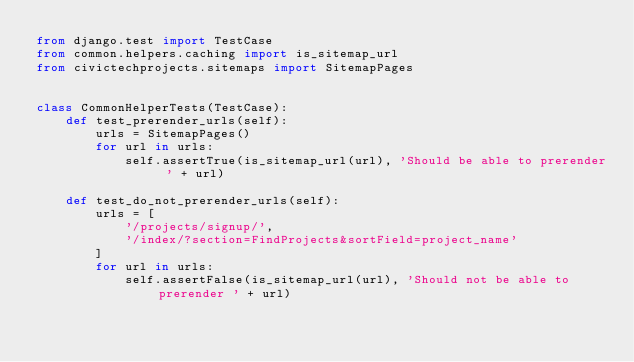Convert code to text. <code><loc_0><loc_0><loc_500><loc_500><_Python_>from django.test import TestCase
from common.helpers.caching import is_sitemap_url
from civictechprojects.sitemaps import SitemapPages


class CommonHelperTests(TestCase):
    def test_prerender_urls(self):
        urls = SitemapPages()
        for url in urls:
            self.assertTrue(is_sitemap_url(url), 'Should be able to prerender ' + url)

    def test_do_not_prerender_urls(self):
        urls = [
            '/projects/signup/',
            '/index/?section=FindProjects&sortField=project_name'
        ]
        for url in urls:
            self.assertFalse(is_sitemap_url(url), 'Should not be able to prerender ' + url)


</code> 